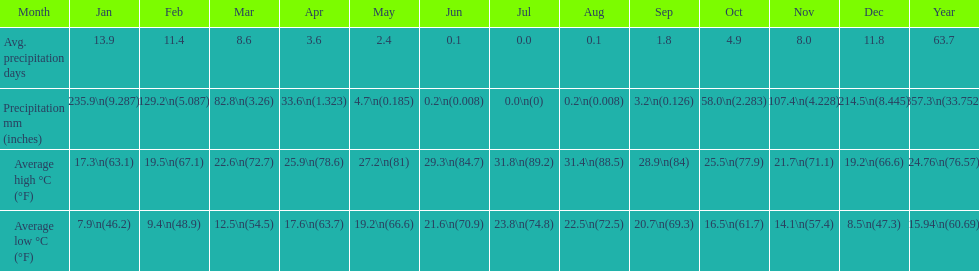What is the month with the lowest average low in haifa? January. 